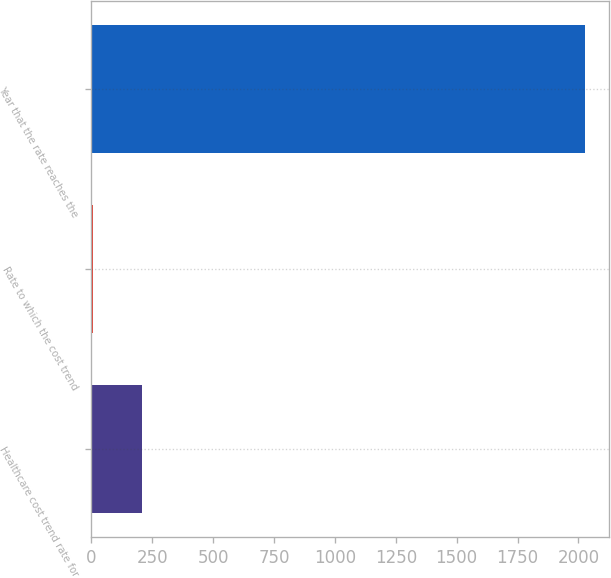Convert chart to OTSL. <chart><loc_0><loc_0><loc_500><loc_500><bar_chart><fcel>Healthcare cost trend rate for<fcel>Rate to which the cost trend<fcel>Year that the rate reaches the<nl><fcel>207.1<fcel>5<fcel>2026<nl></chart> 